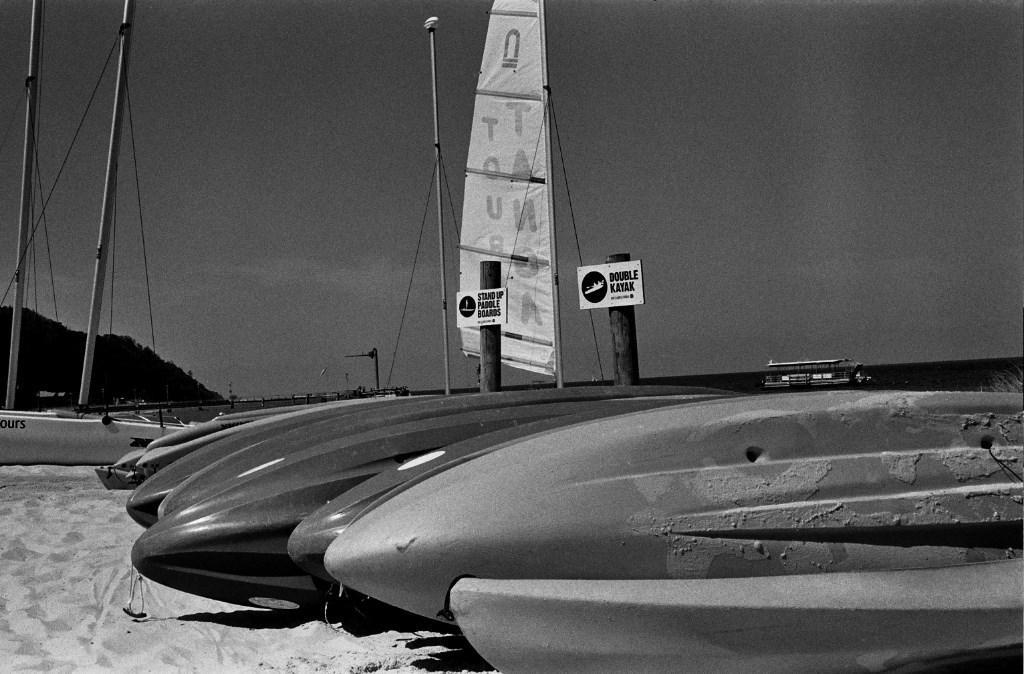Could you give a brief overview of what you see in this image? In this image we can see boats, sand ,water, ship, log, information boards, poles, ropes, hills and sky. 